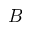Convert formula to latex. <formula><loc_0><loc_0><loc_500><loc_500>B</formula> 